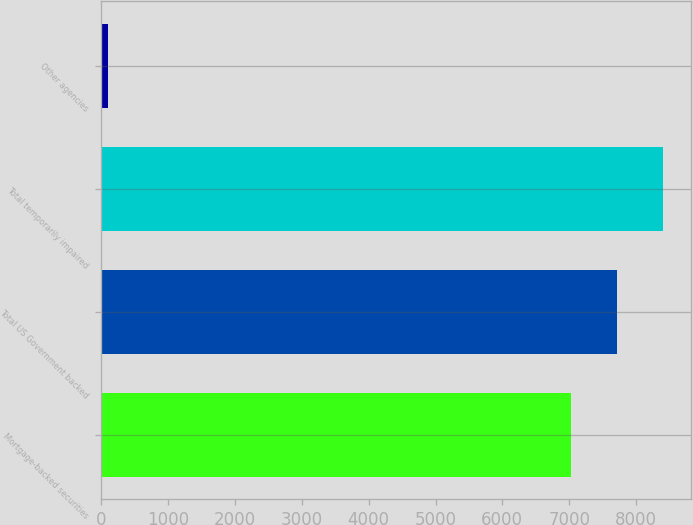Convert chart. <chart><loc_0><loc_0><loc_500><loc_500><bar_chart><fcel>Mortgage-backed securities<fcel>Total US Government backed<fcel>Total temporarily impaired<fcel>Other agencies<nl><fcel>7023<fcel>7715.6<fcel>8408.2<fcel>97<nl></chart> 